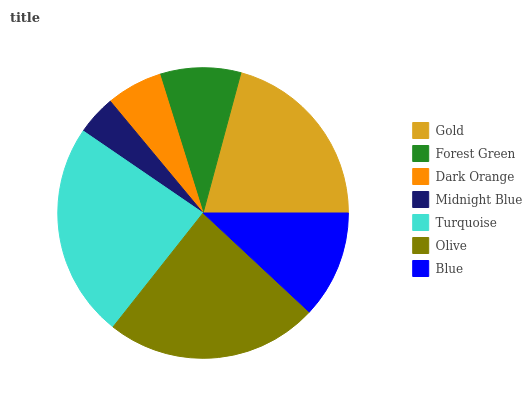Is Midnight Blue the minimum?
Answer yes or no. Yes. Is Turquoise the maximum?
Answer yes or no. Yes. Is Forest Green the minimum?
Answer yes or no. No. Is Forest Green the maximum?
Answer yes or no. No. Is Gold greater than Forest Green?
Answer yes or no. Yes. Is Forest Green less than Gold?
Answer yes or no. Yes. Is Forest Green greater than Gold?
Answer yes or no. No. Is Gold less than Forest Green?
Answer yes or no. No. Is Blue the high median?
Answer yes or no. Yes. Is Blue the low median?
Answer yes or no. Yes. Is Dark Orange the high median?
Answer yes or no. No. Is Turquoise the low median?
Answer yes or no. No. 